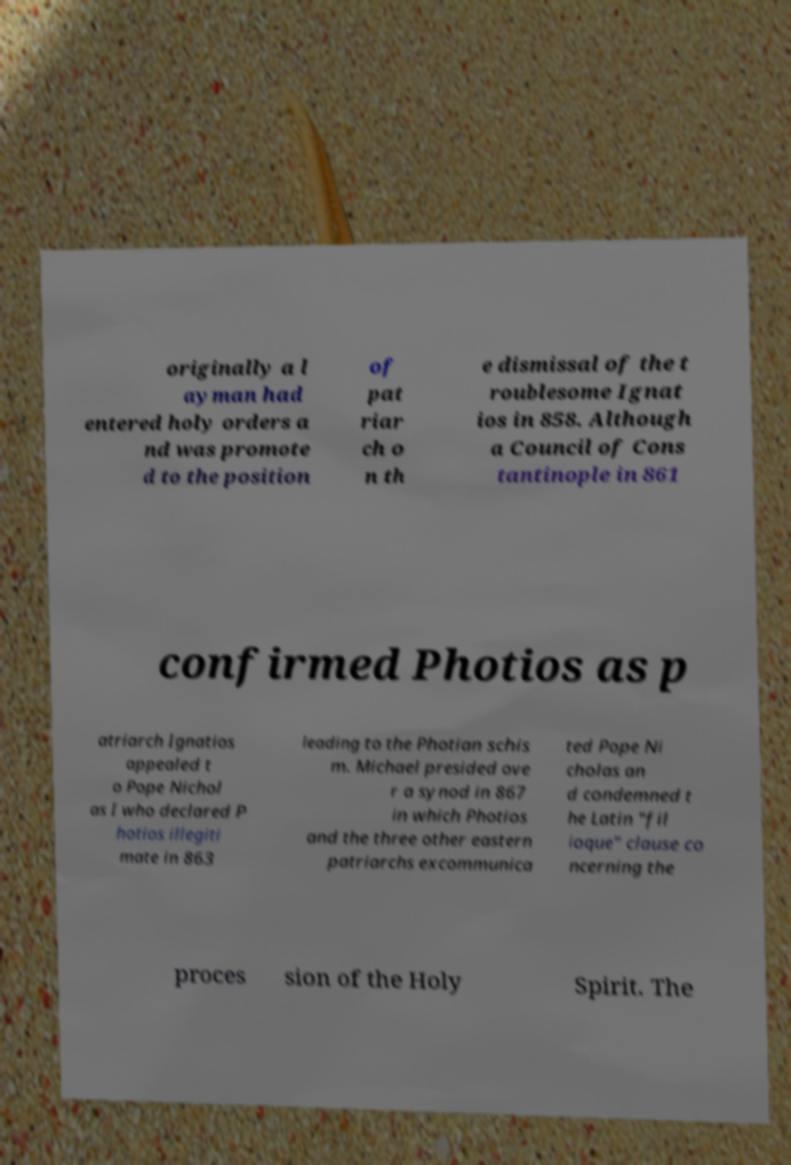What messages or text are displayed in this image? I need them in a readable, typed format. originally a l ayman had entered holy orders a nd was promote d to the position of pat riar ch o n th e dismissal of the t roublesome Ignat ios in 858. Although a Council of Cons tantinople in 861 confirmed Photios as p atriarch Ignatios appealed t o Pope Nichol as I who declared P hotios illegiti mate in 863 leading to the Photian schis m. Michael presided ove r a synod in 867 in which Photios and the three other eastern patriarchs excommunica ted Pope Ni cholas an d condemned t he Latin "fil ioque" clause co ncerning the proces sion of the Holy Spirit. The 